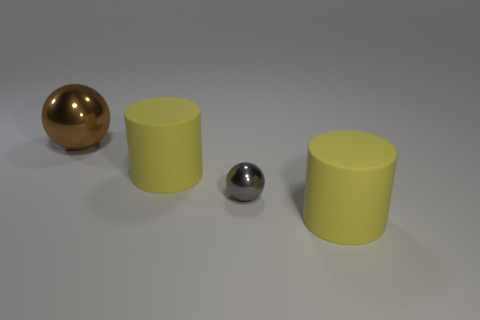Add 2 brown shiny things. How many objects exist? 6 Add 2 big brown metal balls. How many big brown metal balls exist? 3 Subtract 0 blue balls. How many objects are left? 4 Subtract all big green metal cylinders. Subtract all large brown balls. How many objects are left? 3 Add 4 yellow rubber objects. How many yellow rubber objects are left? 6 